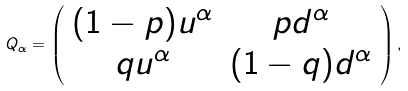<formula> <loc_0><loc_0><loc_500><loc_500>Q _ { \alpha } = \left ( \begin{array} { c c } ( 1 - p ) u ^ { \alpha } & p d ^ { \alpha } \\ q u ^ { \alpha } & ( 1 - q ) d ^ { \alpha } \\ \end{array} \right ) ,</formula> 